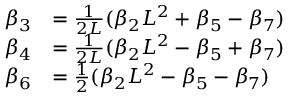<formula> <loc_0><loc_0><loc_500><loc_500>\begin{array} { r l } { \beta _ { 3 } } & { = \frac { 1 } { 2 L } ( \beta _ { 2 } L ^ { 2 } + \beta _ { 5 } - \beta _ { 7 } ) } \\ { \beta _ { 4 } } & { = \frac { 1 } { 2 L } ( \beta _ { 2 } L ^ { 2 } - \beta _ { 5 } + \beta _ { 7 } ) } \\ { \beta _ { 6 } } & { = \frac { 1 } { 2 } ( \beta _ { 2 } L ^ { 2 } - \beta _ { 5 } - \beta _ { 7 } ) } \end{array}</formula> 